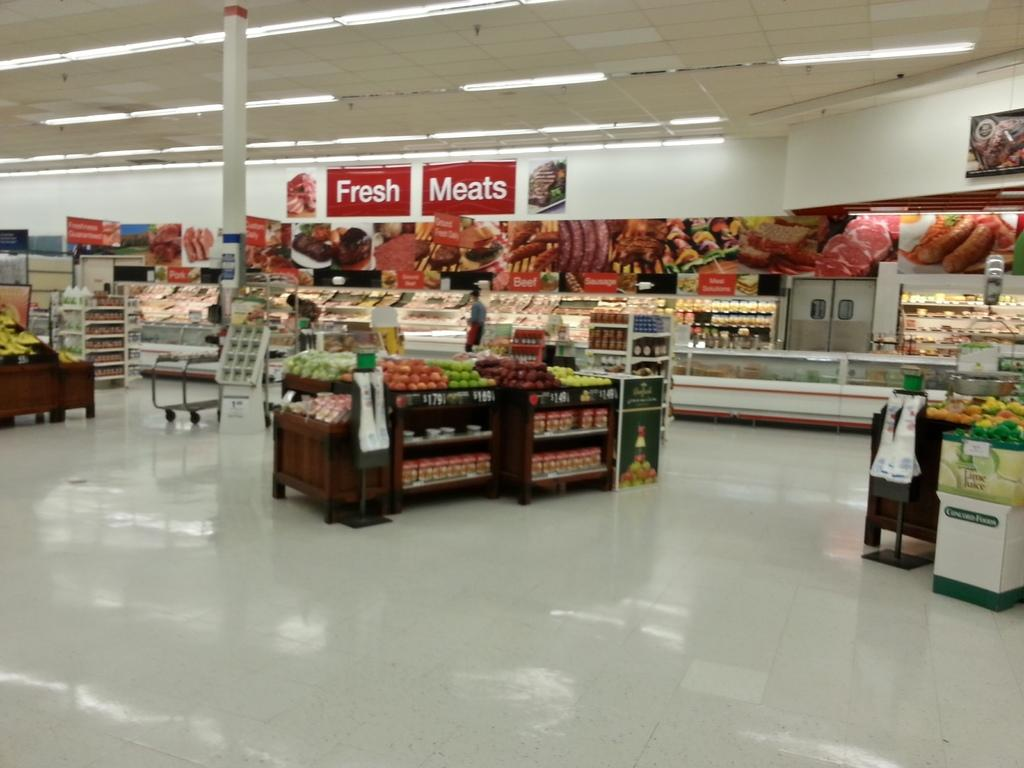<image>
Present a compact description of the photo's key features. a very clean and bright supermarket with a fresh meats section in the back 